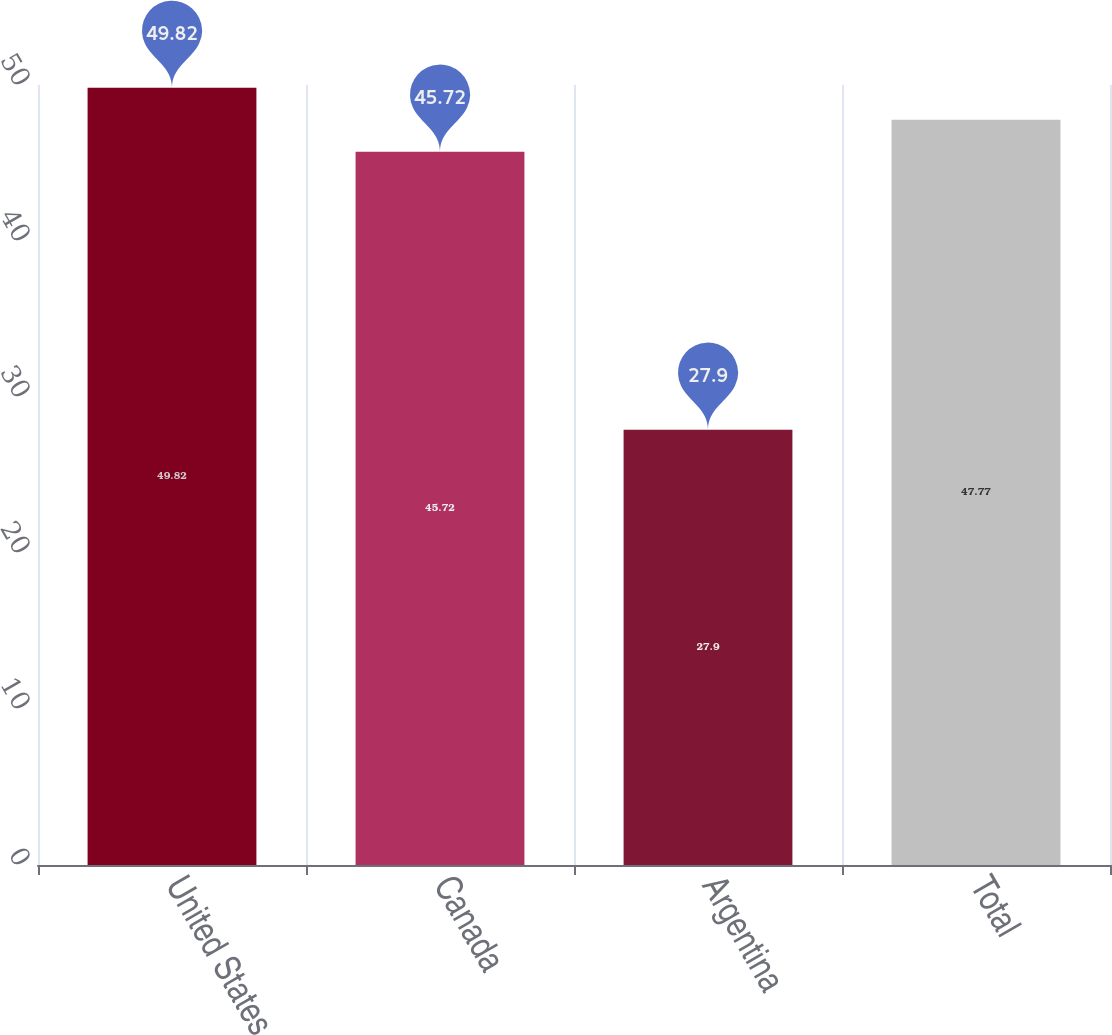<chart> <loc_0><loc_0><loc_500><loc_500><bar_chart><fcel>United States<fcel>Canada<fcel>Argentina<fcel>Total<nl><fcel>49.82<fcel>45.72<fcel>27.9<fcel>47.77<nl></chart> 